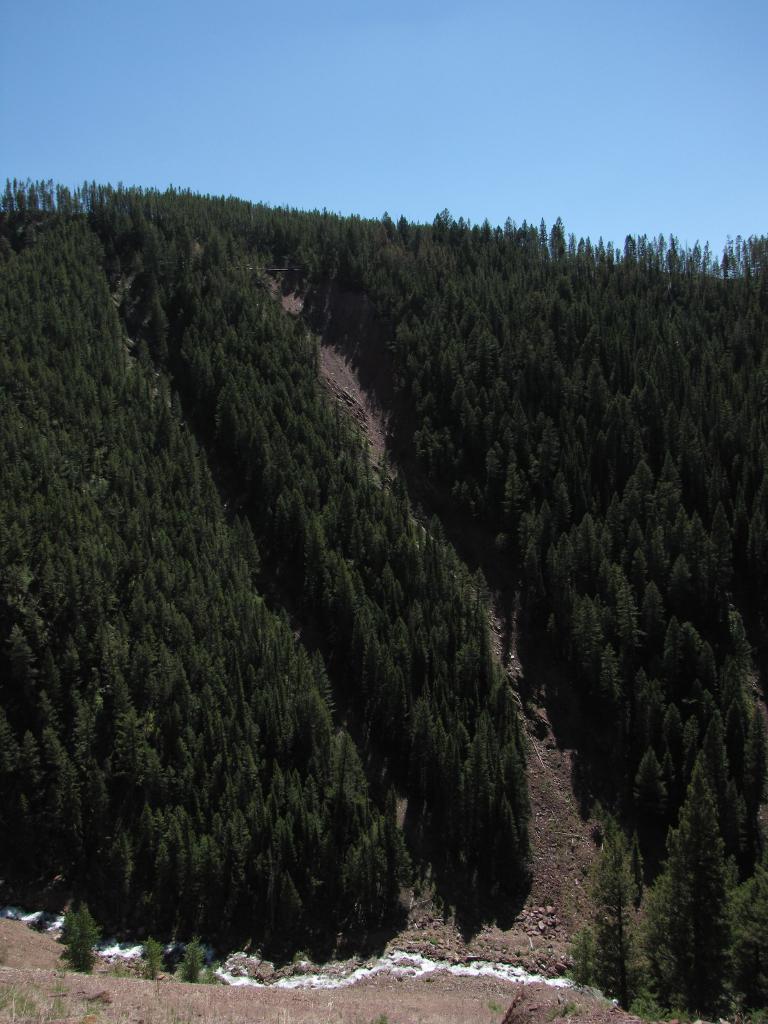Can you describe this image briefly? In this picture I can see the trees on the mountain. At the bottom I can see the water flow. Beside that I can see many small stones. At the top I can see the sky. 